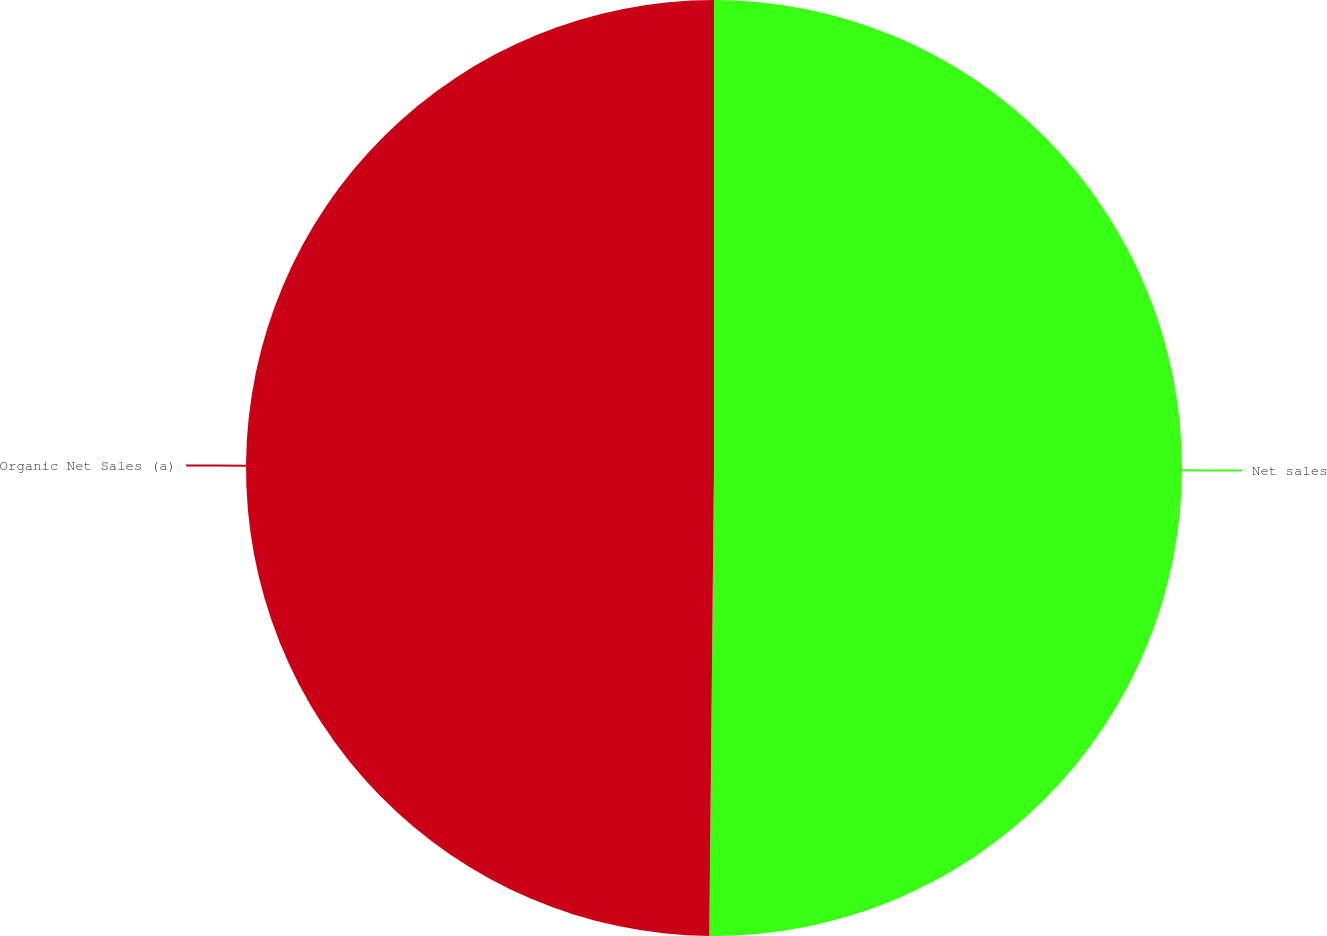<chart> <loc_0><loc_0><loc_500><loc_500><pie_chart><fcel>Net sales<fcel>Organic Net Sales (a)<nl><fcel>50.16%<fcel>49.84%<nl></chart> 